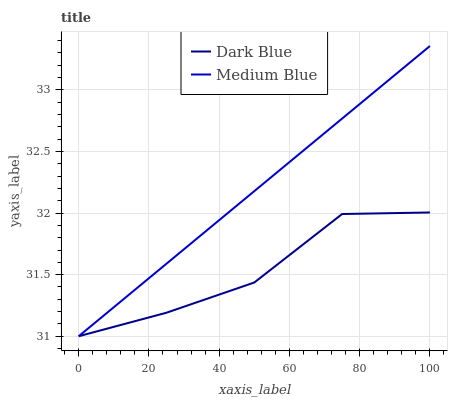Does Dark Blue have the minimum area under the curve?
Answer yes or no. Yes. Does Medium Blue have the maximum area under the curve?
Answer yes or no. Yes. Does Medium Blue have the minimum area under the curve?
Answer yes or no. No. Is Medium Blue the smoothest?
Answer yes or no. Yes. Is Dark Blue the roughest?
Answer yes or no. Yes. Is Medium Blue the roughest?
Answer yes or no. No. Does Dark Blue have the lowest value?
Answer yes or no. Yes. Does Medium Blue have the highest value?
Answer yes or no. Yes. Does Dark Blue intersect Medium Blue?
Answer yes or no. Yes. Is Dark Blue less than Medium Blue?
Answer yes or no. No. Is Dark Blue greater than Medium Blue?
Answer yes or no. No. 